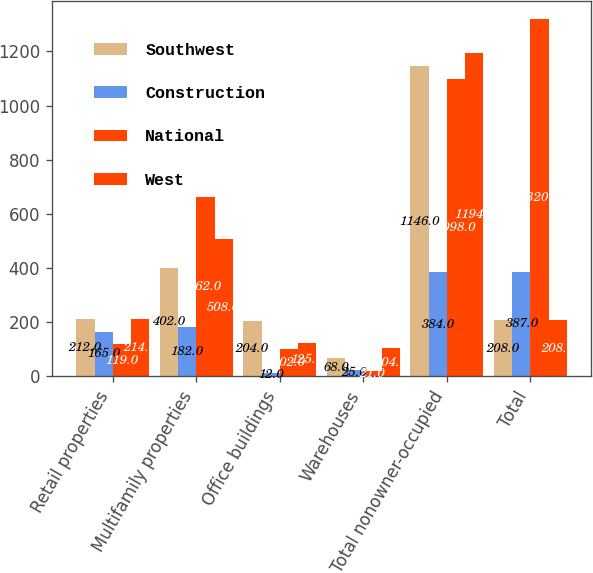Convert chart. <chart><loc_0><loc_0><loc_500><loc_500><stacked_bar_chart><ecel><fcel>Retail properties<fcel>Multifamily properties<fcel>Office buildings<fcel>Warehouses<fcel>Total nonowner-occupied<fcel>Total<nl><fcel>Southwest<fcel>212<fcel>402<fcel>204<fcel>68<fcel>1146<fcel>208<nl><fcel>Construction<fcel>165<fcel>182<fcel>12<fcel>25<fcel>384<fcel>387<nl><fcel>National<fcel>119<fcel>662<fcel>102<fcel>21<fcel>1098<fcel>1320<nl><fcel>West<fcel>214<fcel>508<fcel>125<fcel>104<fcel>1194<fcel>208<nl></chart> 